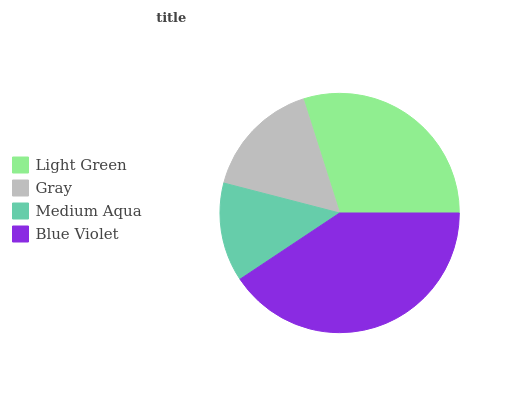Is Medium Aqua the minimum?
Answer yes or no. Yes. Is Blue Violet the maximum?
Answer yes or no. Yes. Is Gray the minimum?
Answer yes or no. No. Is Gray the maximum?
Answer yes or no. No. Is Light Green greater than Gray?
Answer yes or no. Yes. Is Gray less than Light Green?
Answer yes or no. Yes. Is Gray greater than Light Green?
Answer yes or no. No. Is Light Green less than Gray?
Answer yes or no. No. Is Light Green the high median?
Answer yes or no. Yes. Is Gray the low median?
Answer yes or no. Yes. Is Medium Aqua the high median?
Answer yes or no. No. Is Light Green the low median?
Answer yes or no. No. 